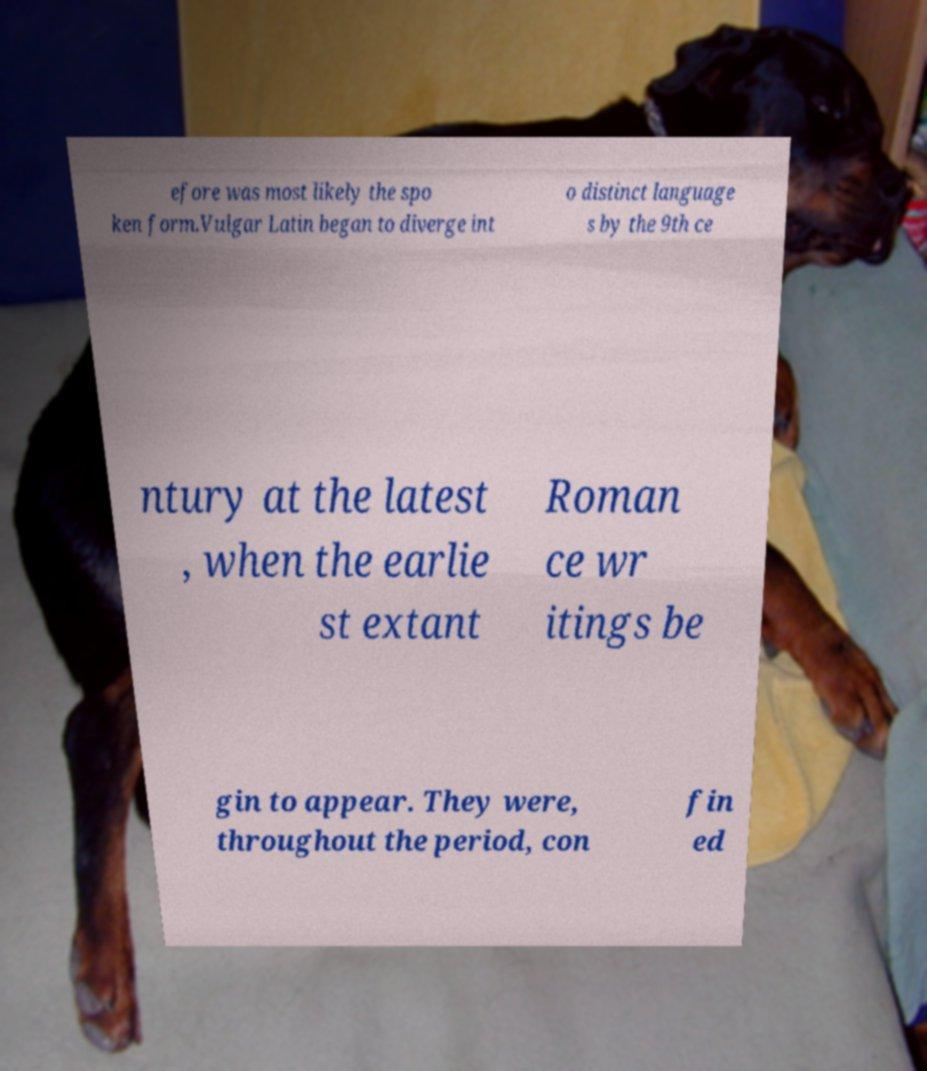Can you read and provide the text displayed in the image?This photo seems to have some interesting text. Can you extract and type it out for me? efore was most likely the spo ken form.Vulgar Latin began to diverge int o distinct language s by the 9th ce ntury at the latest , when the earlie st extant Roman ce wr itings be gin to appear. They were, throughout the period, con fin ed 